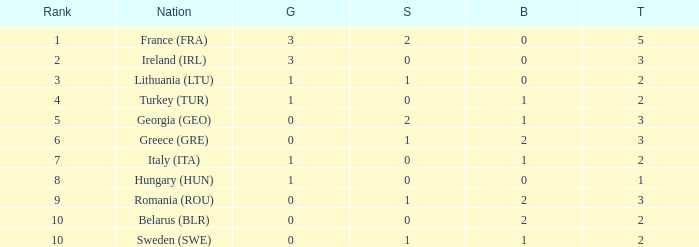What are the most bronze medals in a rank more than 1 with a total larger than 3? None. Could you parse the entire table as a dict? {'header': ['Rank', 'Nation', 'G', 'S', 'B', 'T'], 'rows': [['1', 'France (FRA)', '3', '2', '0', '5'], ['2', 'Ireland (IRL)', '3', '0', '0', '3'], ['3', 'Lithuania (LTU)', '1', '1', '0', '2'], ['4', 'Turkey (TUR)', '1', '0', '1', '2'], ['5', 'Georgia (GEO)', '0', '2', '1', '3'], ['6', 'Greece (GRE)', '0', '1', '2', '3'], ['7', 'Italy (ITA)', '1', '0', '1', '2'], ['8', 'Hungary (HUN)', '1', '0', '0', '1'], ['9', 'Romania (ROU)', '0', '1', '2', '3'], ['10', 'Belarus (BLR)', '0', '0', '2', '2'], ['10', 'Sweden (SWE)', '0', '1', '1', '2']]} 